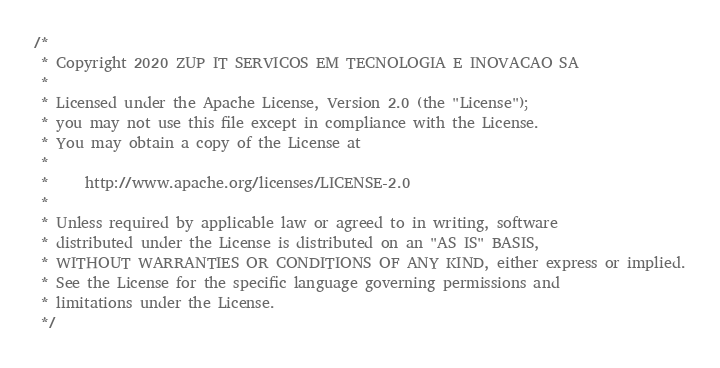<code> <loc_0><loc_0><loc_500><loc_500><_Kotlin_>/*
 * Copyright 2020 ZUP IT SERVICOS EM TECNOLOGIA E INOVACAO SA
 *
 * Licensed under the Apache License, Version 2.0 (the "License");
 * you may not use this file except in compliance with the License.
 * You may obtain a copy of the License at
 *
 *     http://www.apache.org/licenses/LICENSE-2.0
 *
 * Unless required by applicable law or agreed to in writing, software
 * distributed under the License is distributed on an "AS IS" BASIS,
 * WITHOUT WARRANTIES OR CONDITIONS OF ANY KIND, either express or implied.
 * See the License for the specific language governing permissions and
 * limitations under the License.
 */
</code> 